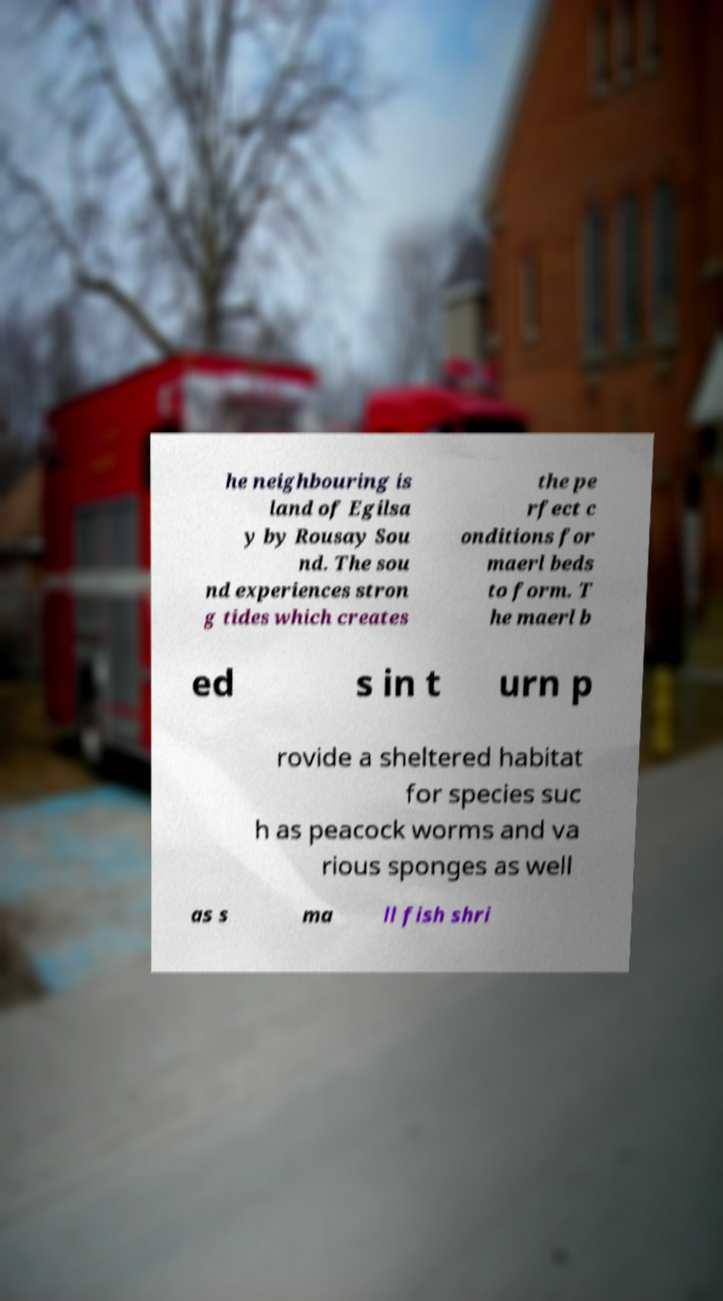For documentation purposes, I need the text within this image transcribed. Could you provide that? he neighbouring is land of Egilsa y by Rousay Sou nd. The sou nd experiences stron g tides which creates the pe rfect c onditions for maerl beds to form. T he maerl b ed s in t urn p rovide a sheltered habitat for species suc h as peacock worms and va rious sponges as well as s ma ll fish shri 